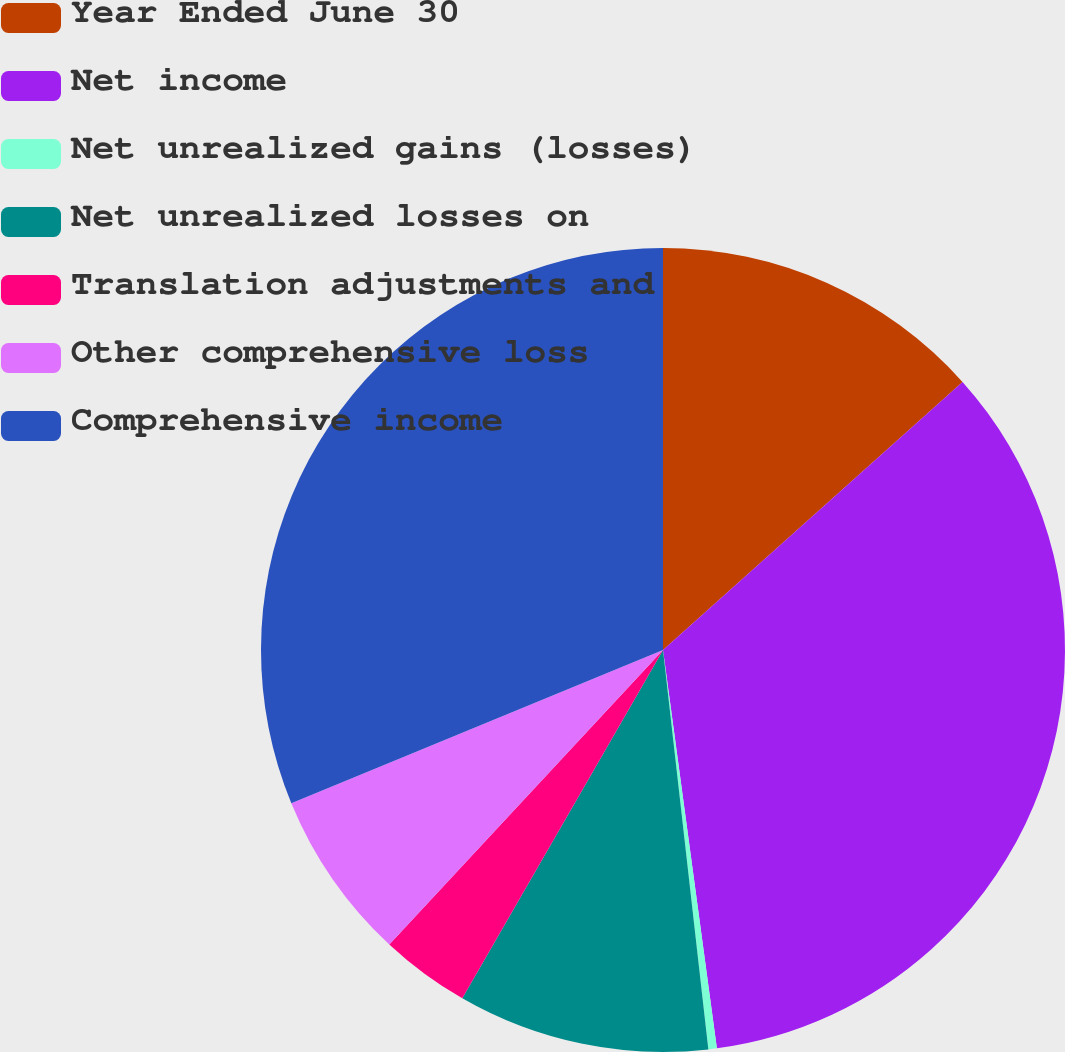<chart> <loc_0><loc_0><loc_500><loc_500><pie_chart><fcel>Year Ended June 30<fcel>Net income<fcel>Net unrealized gains (losses)<fcel>Net unrealized losses on<fcel>Translation adjustments and<fcel>Other comprehensive loss<fcel>Comprehensive income<nl><fcel>13.38%<fcel>34.48%<fcel>0.34%<fcel>10.12%<fcel>3.6%<fcel>6.86%<fcel>31.22%<nl></chart> 